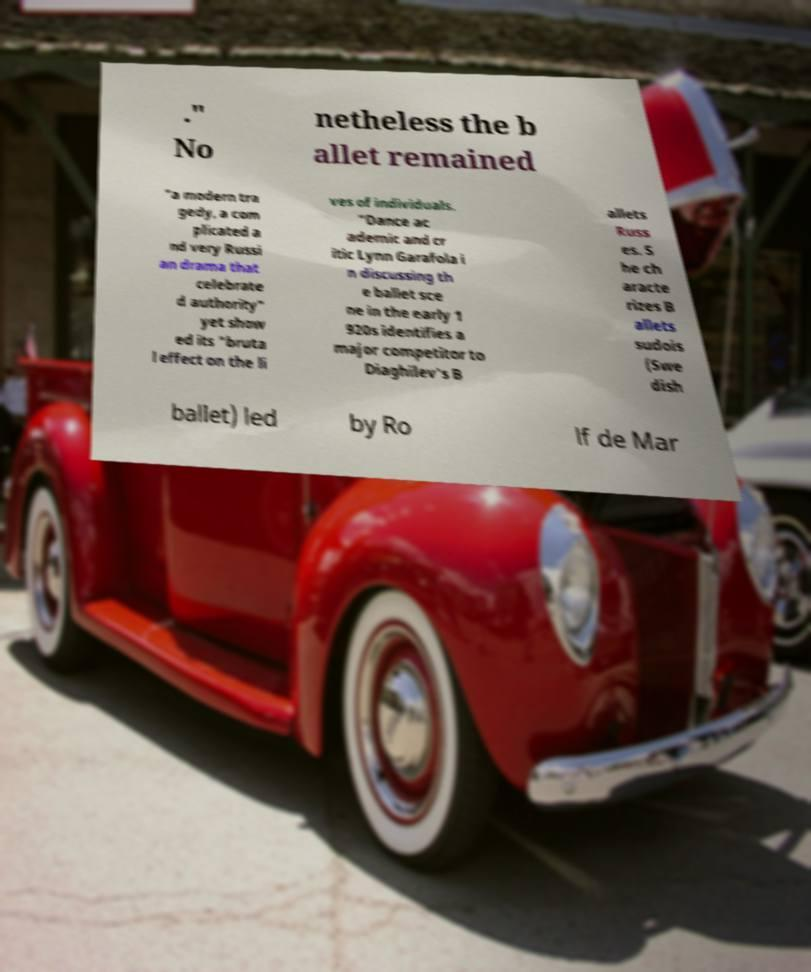What messages or text are displayed in this image? I need them in a readable, typed format. ." No netheless the b allet remained "a modern tra gedy, a com plicated a nd very Russi an drama that celebrate d authority" yet show ed its "bruta l effect on the li ves of individuals. "Dance ac ademic and cr itic Lynn Garafola i n discussing th e ballet sce ne in the early 1 920s identifies a major competitor to Diaghilev's B allets Russ es. S he ch aracte rizes B allets sudois (Swe dish ballet) led by Ro lf de Mar 